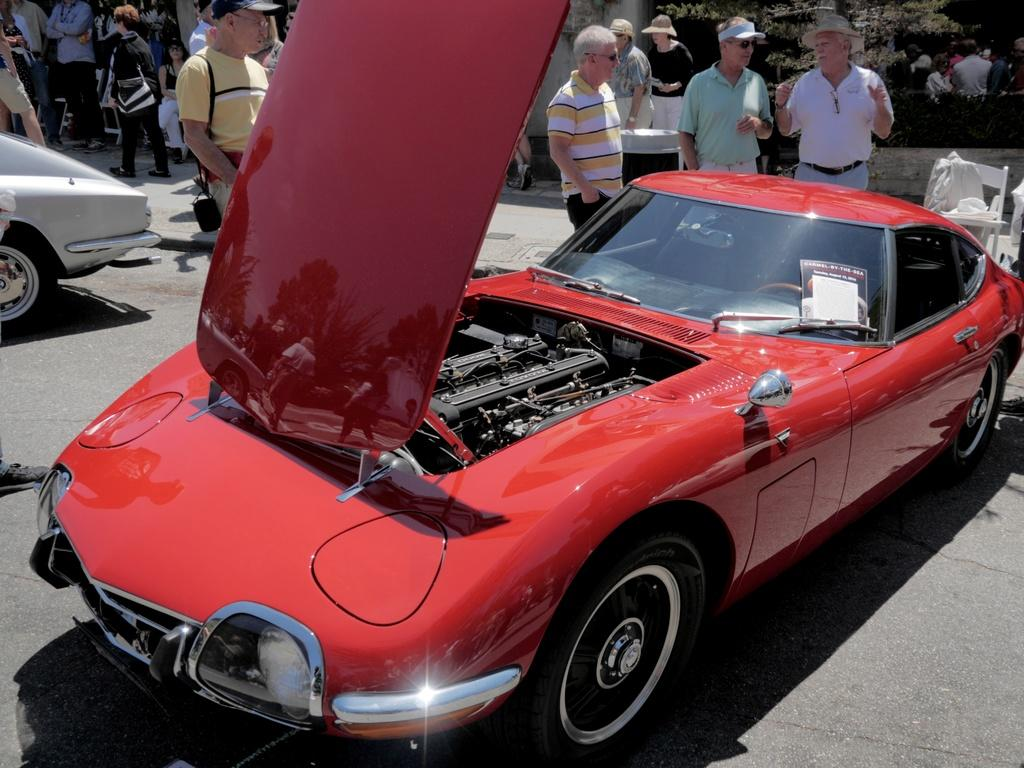Where was the image taken? The image is taken outside. What is the main subject in the middle of the image? There is a car in the middle of the image. What color is the car? The car is red. Can you describe the people in the image? There are people standing at the top of the image. What page of the guidebook is the snake mentioned on? There is no guidebook or snake present in the image. 